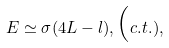Convert formula to latex. <formula><loc_0><loc_0><loc_500><loc_500>E \simeq \sigma ( 4 L - l ) , { \mbox ( c . t . ) } ,</formula> 